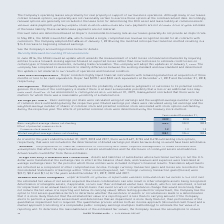According to Roper Technologies's financial document, How is basic earning per share calculated? using net earnings and the weighted-average number of shares of common stock outstanding during the respective year. The document states: "Share — Basic earnings per share were calculated using net earnings and the weighted-average number of shares of common stock outstanding during the r..." Also, How many outstanding stock options would have been antidilutive for fiscal years 2017 and 2018, respectively? The document shows two values: 0.478 and 0.724. From the document: "2019, 2018 and 2017, there were 0.627, 0.724 and 0.478 outstanding stock options, respectively, that were not included in the determination of diluted..." Also, How are the effects of potential common stock determined? using the treasury stock method. The document states: "effects of potential common stock were determined using the treasury stock method:..." Also, can you calculate: What is the average of basic weighted-average shares outstanding from 2017 to 2019? To answer this question, I need to perform calculations using the financial data. The calculation is: (103.9+103.2+102.2)/3 , which equals 103.1. This is based on the information: "c weighted-average shares outstanding 103.9 103.2 102.2 Basic weighted-average shares outstanding 103.9 103.2 102.2 Basic weighted-average shares outstanding 103.9 103.2 102.2..." The key data points involved are: 102.2, 103.2, 103.9. Also, can you calculate: What is the proportion of basic over diluted weighted-average shares outstanding in 2017? Based on the calculation: 102.2/103.5 , the result is 0.99. This is based on the information: "d weighted-average shares outstanding 105.1 104.4 103.5 c weighted-average shares outstanding 103.9 103.2 102.2..." The key data points involved are: 102.2, 103.5. Also, can you calculate: What is the change in Diluted weighted-average shares outstanding between 2018 and 2019? Based on the calculation: 105.1-104.4, the result is 0.7. This is based on the information: "Diluted weighted-average shares outstanding 105.1 104.4 103.5 Diluted weighted-average shares outstanding 105.1 104.4 103.5..." The key data points involved are: 104.4, 105.1. 